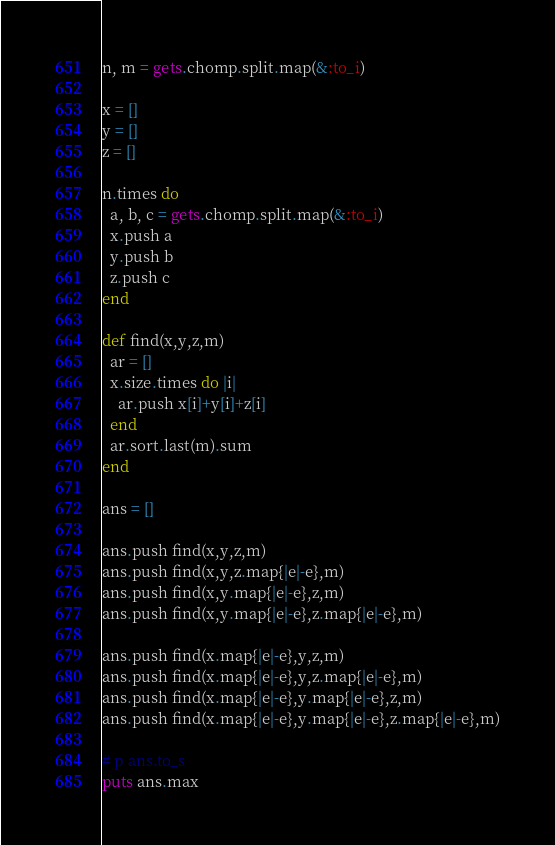<code> <loc_0><loc_0><loc_500><loc_500><_Ruby_>n, m = gets.chomp.split.map(&:to_i)

x = []
y = []
z = []

n.times do
  a, b, c = gets.chomp.split.map(&:to_i)
  x.push a
  y.push b
  z.push c
end

def find(x,y,z,m)
  ar = []
  x.size.times do |i|
    ar.push x[i]+y[i]+z[i]
  end
  ar.sort.last(m).sum
end

ans = []

ans.push find(x,y,z,m)
ans.push find(x,y,z.map{|e|-e},m)
ans.push find(x,y.map{|e|-e},z,m)
ans.push find(x,y.map{|e|-e},z.map{|e|-e},m)

ans.push find(x.map{|e|-e},y,z,m)
ans.push find(x.map{|e|-e},y,z.map{|e|-e},m)
ans.push find(x.map{|e|-e},y.map{|e|-e},z,m)
ans.push find(x.map{|e|-e},y.map{|e|-e},z.map{|e|-e},m)

# p ans.to_s
puts ans.max
</code> 